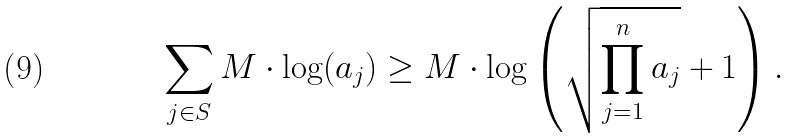<formula> <loc_0><loc_0><loc_500><loc_500>& \sum _ { j \in S } M \cdot \log ( a _ { j } ) \geq M \cdot \log \left ( \sqrt { \prod _ { j = 1 } ^ { n } a _ { j } } + 1 \right ) .</formula> 